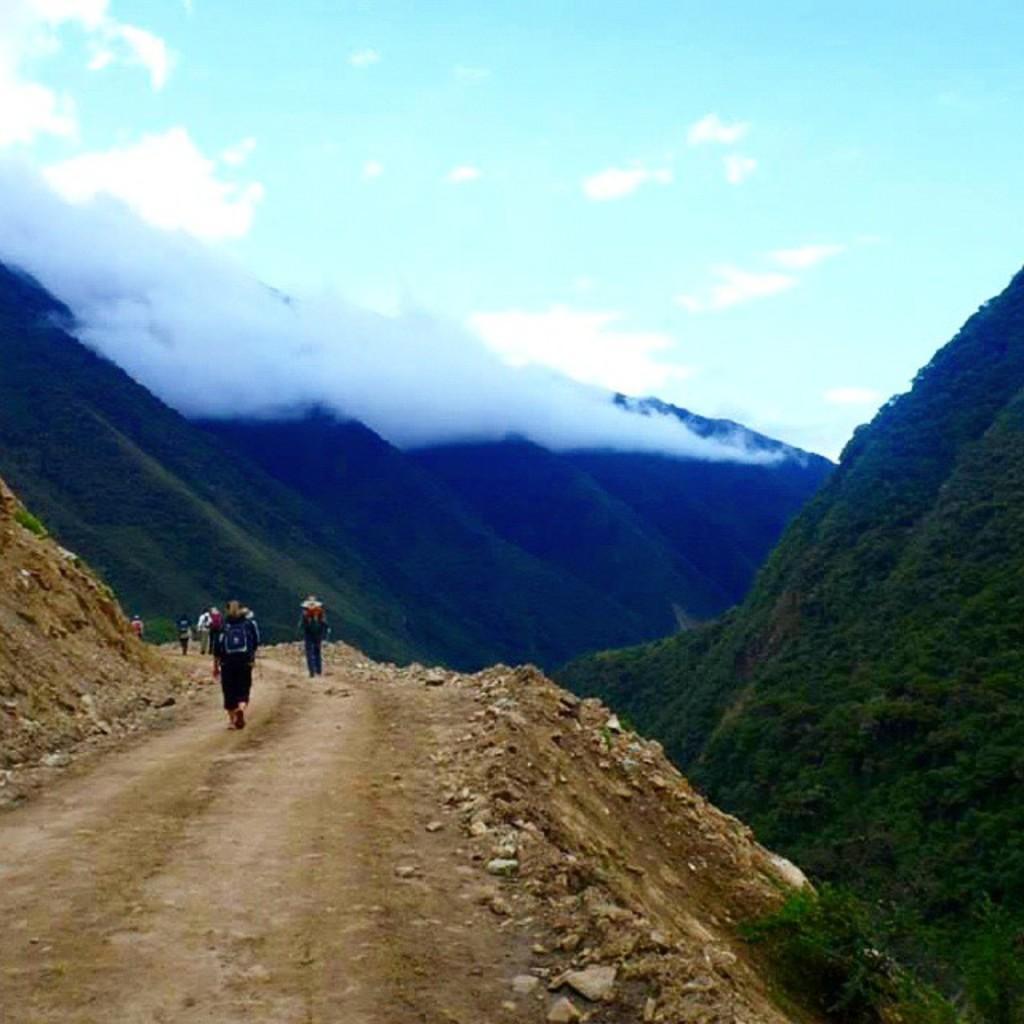What are the people in the image doing? The people in the image are walking on the road. What natural features can be seen in the background of the image? There are mountains visible in the image. What is the weather like in the image? There is snow in the image, indicating a cold or wintry climate. What is visible in the sky in the image? There are clouds in the sky in the image. What year is depicted in the image? The year is not visible or mentioned in the image, so it cannot be determined. What type of basin can be seen in the image? There is no basin present in the image. 